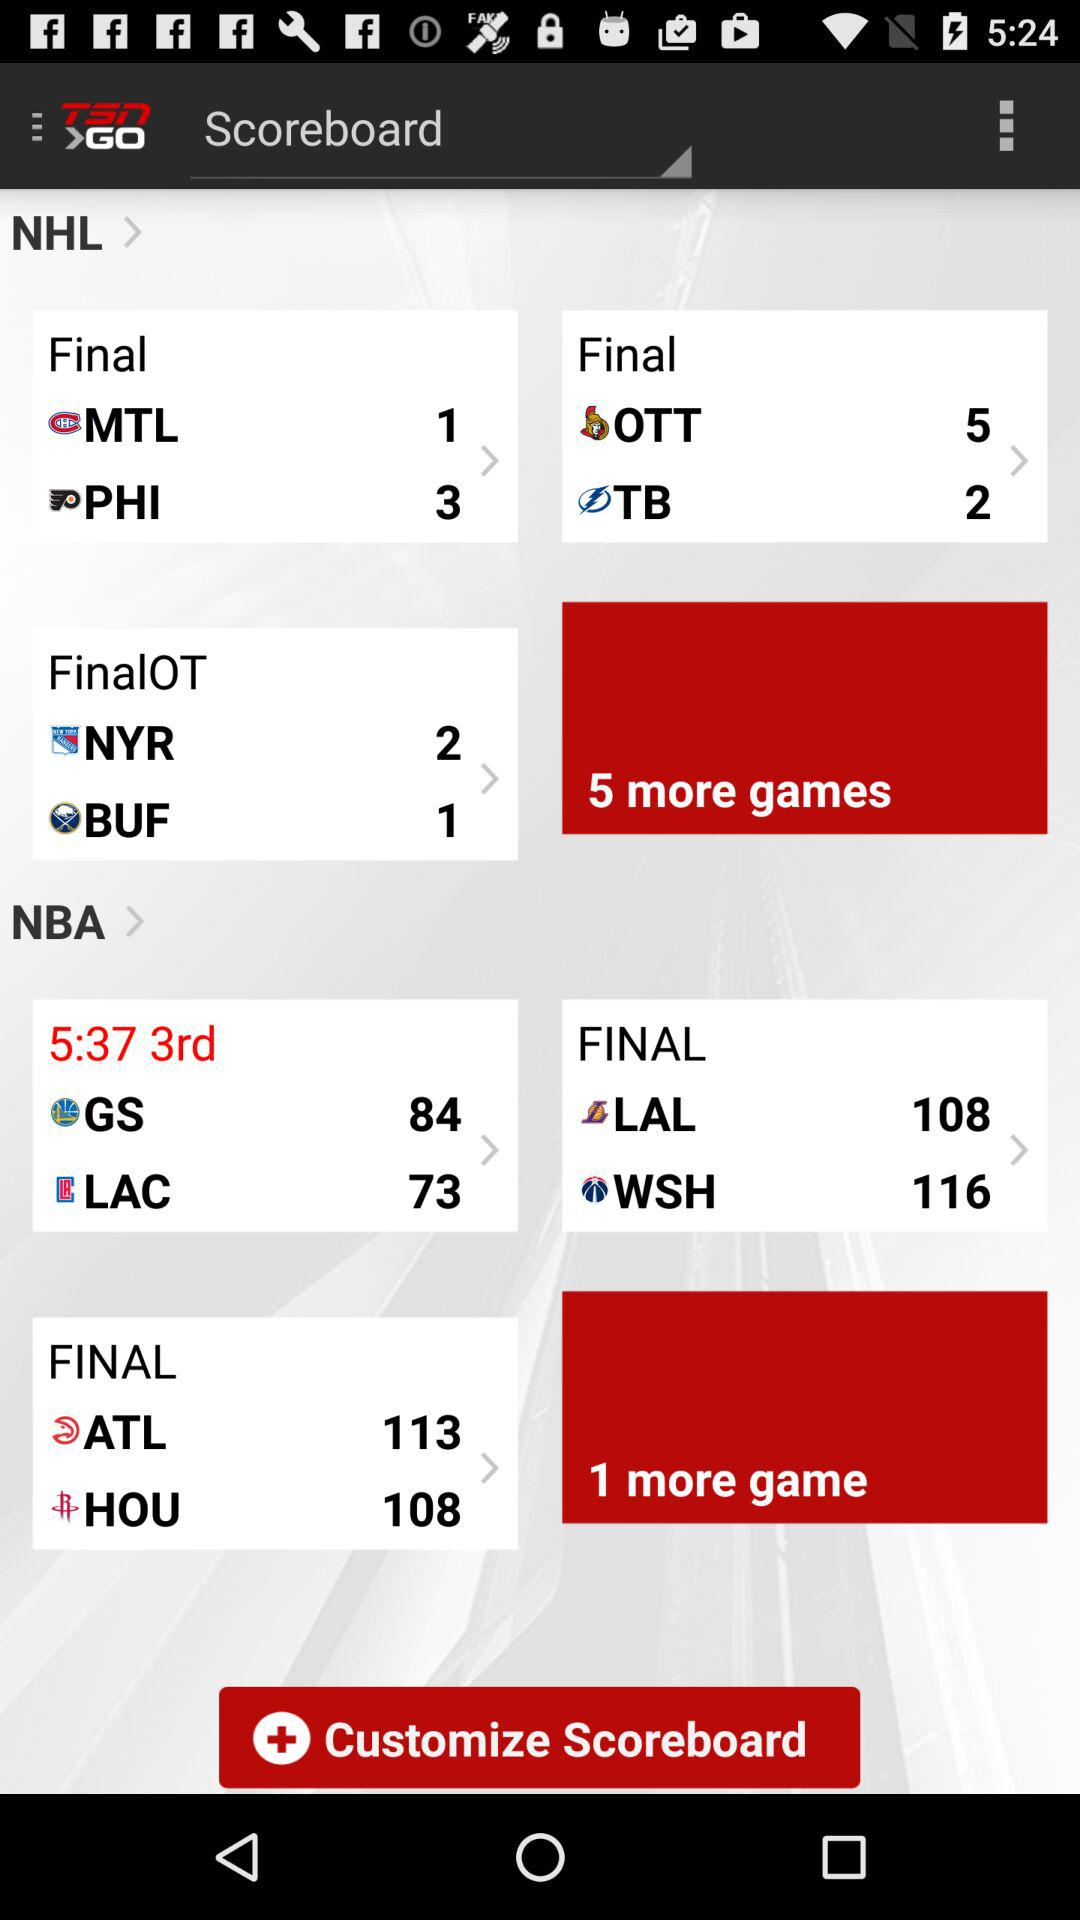What is the duration of the final match between "MLT" and "PHI"?
When the provided information is insufficient, respond with <no answer>. <no answer> 